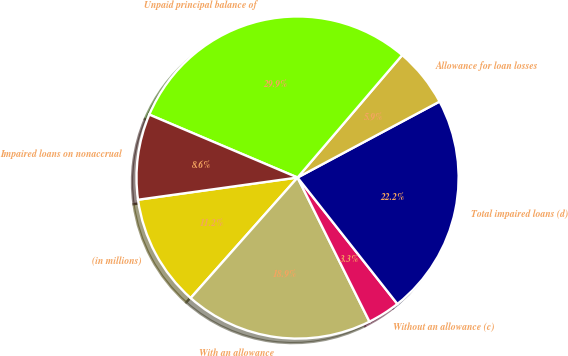<chart> <loc_0><loc_0><loc_500><loc_500><pie_chart><fcel>(in millions)<fcel>With an allowance<fcel>Without an allowance (c)<fcel>Total impaired loans (d)<fcel>Allowance for loan losses<fcel>Unpaid principal balance of<fcel>Impaired loans on nonaccrual<nl><fcel>11.25%<fcel>18.92%<fcel>3.27%<fcel>22.18%<fcel>5.93%<fcel>29.87%<fcel>8.59%<nl></chart> 